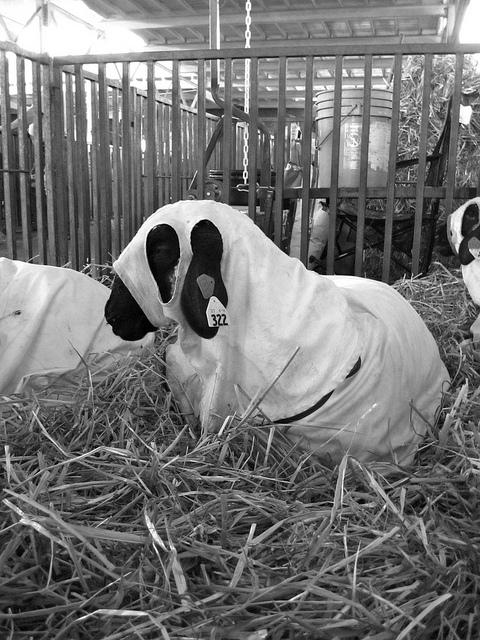The first digit of the number that is clipped to the ear is included in what number?

Choices:
A) 444
B) 280
C) 515
D) 305 305 